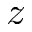Convert formula to latex. <formula><loc_0><loc_0><loc_500><loc_500>z</formula> 